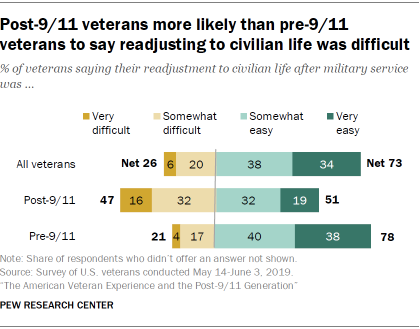Point out several critical features in this image. According to a survey of all veterans, 34% believe that civilian life is very easy. 